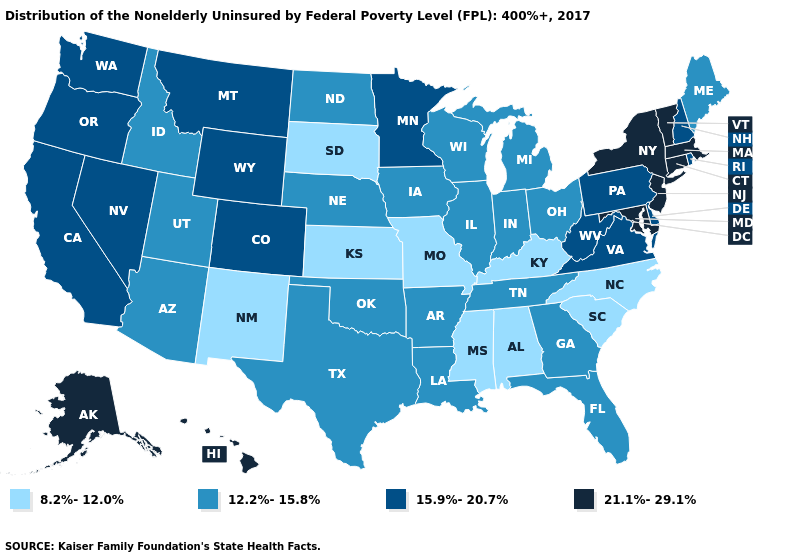What is the value of Maine?
Concise answer only. 12.2%-15.8%. Among the states that border West Virginia , does Kentucky have the lowest value?
Keep it brief. Yes. What is the value of Nevada?
Keep it brief. 15.9%-20.7%. Does Oregon have the highest value in the USA?
Keep it brief. No. Name the states that have a value in the range 12.2%-15.8%?
Answer briefly. Arizona, Arkansas, Florida, Georgia, Idaho, Illinois, Indiana, Iowa, Louisiana, Maine, Michigan, Nebraska, North Dakota, Ohio, Oklahoma, Tennessee, Texas, Utah, Wisconsin. What is the value of Hawaii?
Keep it brief. 21.1%-29.1%. Name the states that have a value in the range 8.2%-12.0%?
Keep it brief. Alabama, Kansas, Kentucky, Mississippi, Missouri, New Mexico, North Carolina, South Carolina, South Dakota. Does Wisconsin have the same value as Michigan?
Write a very short answer. Yes. What is the value of Maine?
Give a very brief answer. 12.2%-15.8%. What is the lowest value in the West?
Keep it brief. 8.2%-12.0%. Name the states that have a value in the range 12.2%-15.8%?
Concise answer only. Arizona, Arkansas, Florida, Georgia, Idaho, Illinois, Indiana, Iowa, Louisiana, Maine, Michigan, Nebraska, North Dakota, Ohio, Oklahoma, Tennessee, Texas, Utah, Wisconsin. Name the states that have a value in the range 8.2%-12.0%?
Concise answer only. Alabama, Kansas, Kentucky, Mississippi, Missouri, New Mexico, North Carolina, South Carolina, South Dakota. What is the highest value in the Northeast ?
Keep it brief. 21.1%-29.1%. What is the value of Nevada?
Write a very short answer. 15.9%-20.7%. Does Mississippi have a lower value than South Carolina?
Give a very brief answer. No. 